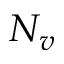Convert formula to latex. <formula><loc_0><loc_0><loc_500><loc_500>N _ { v }</formula> 